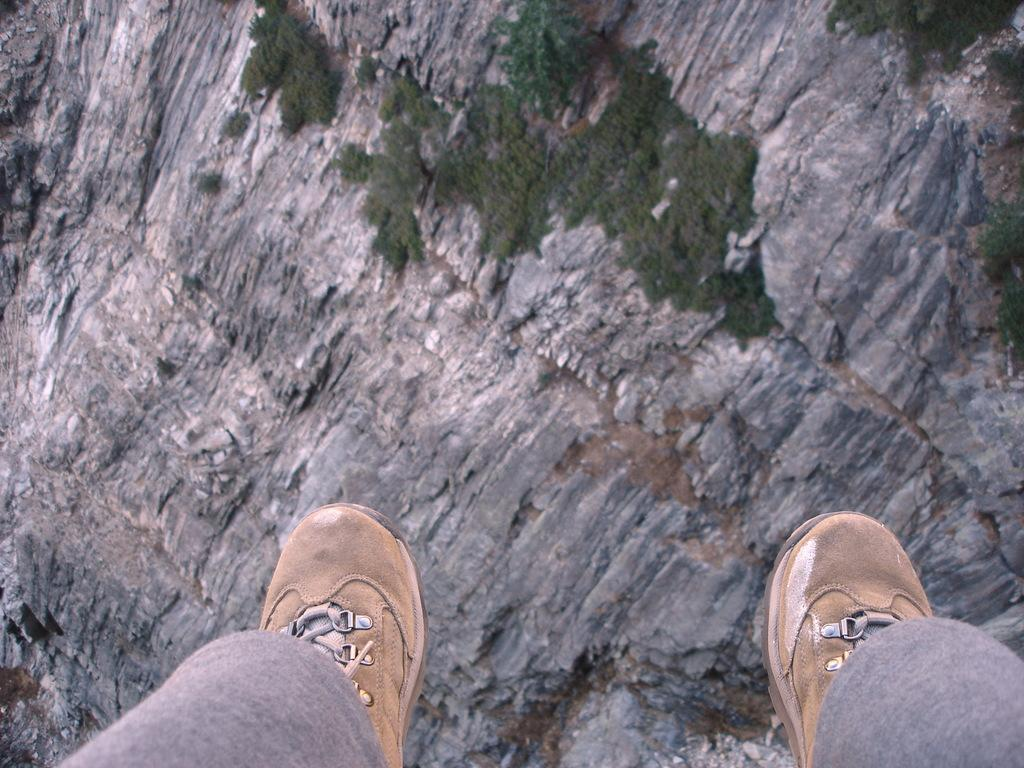What can be seen at the bottom of the image? There are two legs with shoes in the image. What is the main object in the middle of the image? There is a rock in the middle of the image. What type of vegetation is present on the rock? There is grass on the rock in the image. How many necks of dinosaurs can be seen in the image? There are no dinosaurs present in the image, so no necks can be seen. What type of plants are growing on the rock in the image? The only vegetation mentioned in the image is grass, so there are no other plants present. 